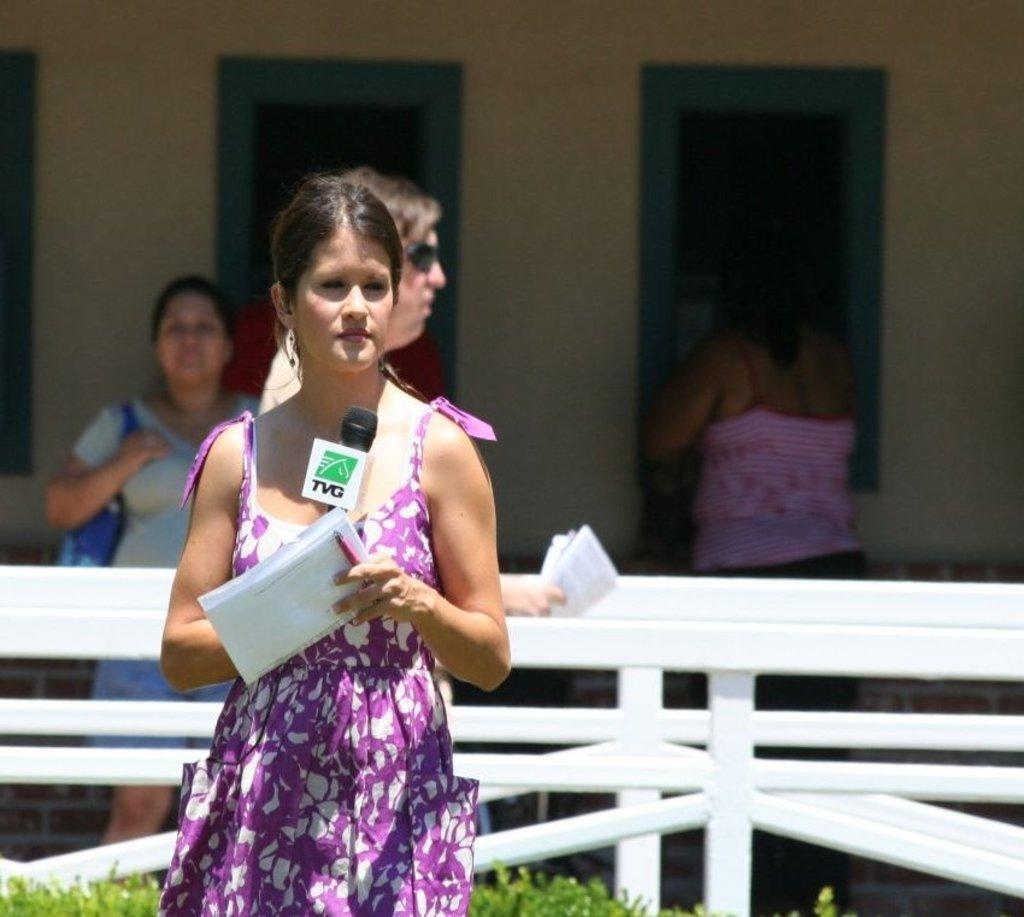Please provide a concise description of this image. In this picture I can see a person standing and holding papers, pen and a mike, there are few people standing, there is fence, and in the background there is a wall with windows. 